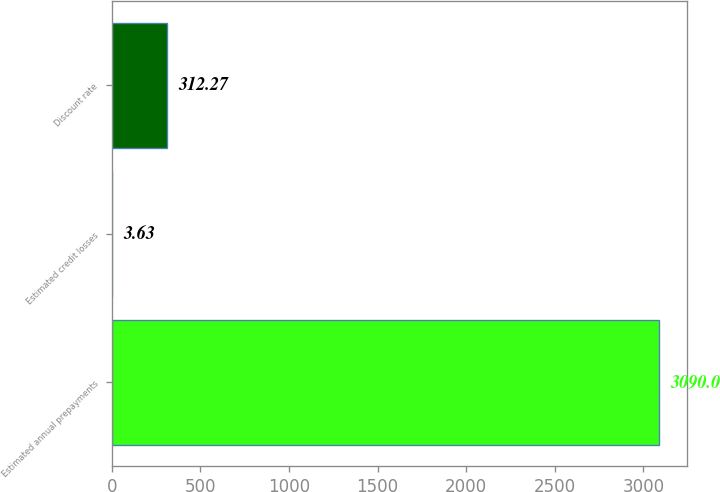Convert chart to OTSL. <chart><loc_0><loc_0><loc_500><loc_500><bar_chart><fcel>Estimated annual prepayments<fcel>Estimated credit losses<fcel>Discount rate<nl><fcel>3090<fcel>3.63<fcel>312.27<nl></chart> 